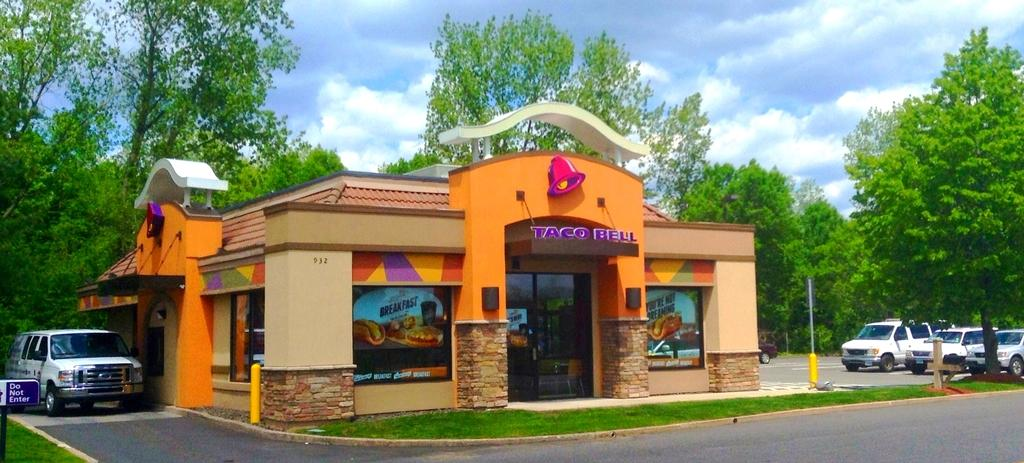What type of structure is present in the image? There is a house in the image. What can be seen near the house? There are cars beside the house. What is the purpose of the sign board in the image? The purpose of the sign board in the image is not specified, but it could be for advertising, directions, or information. What type of vegetation is present in the image? There are trees in the image. What is visible in the sky in the image? There are clouds visible in the image. What type of property is being looked at in the image? There is no indication in the image that someone is looking at a property. The image simply shows a house, cars, a sign board, trees, and clouds. 